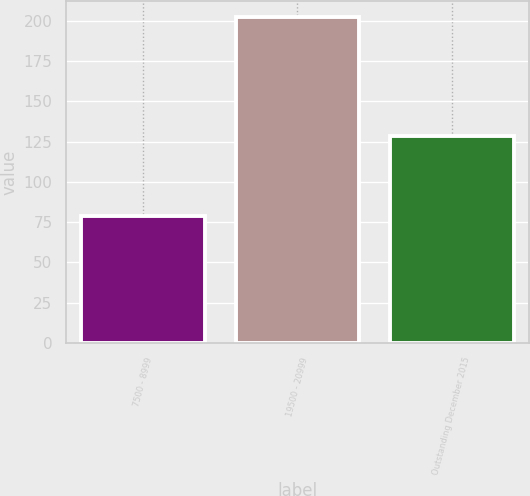Convert chart to OTSL. <chart><loc_0><loc_0><loc_500><loc_500><bar_chart><fcel>7500 - 8999<fcel>19500 - 20999<fcel>Outstanding December 2015<nl><fcel>78.78<fcel>202.27<fcel>128.79<nl></chart> 